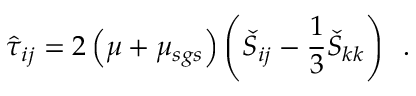Convert formula to latex. <formula><loc_0><loc_0><loc_500><loc_500>\hat { \tau } _ { i j } = 2 \left ( \mu + \mu _ { s g s } \right ) \left ( \check { S } _ { i j } - \frac { 1 } { 3 } \check { S } _ { k k } \right ) \, .</formula> 